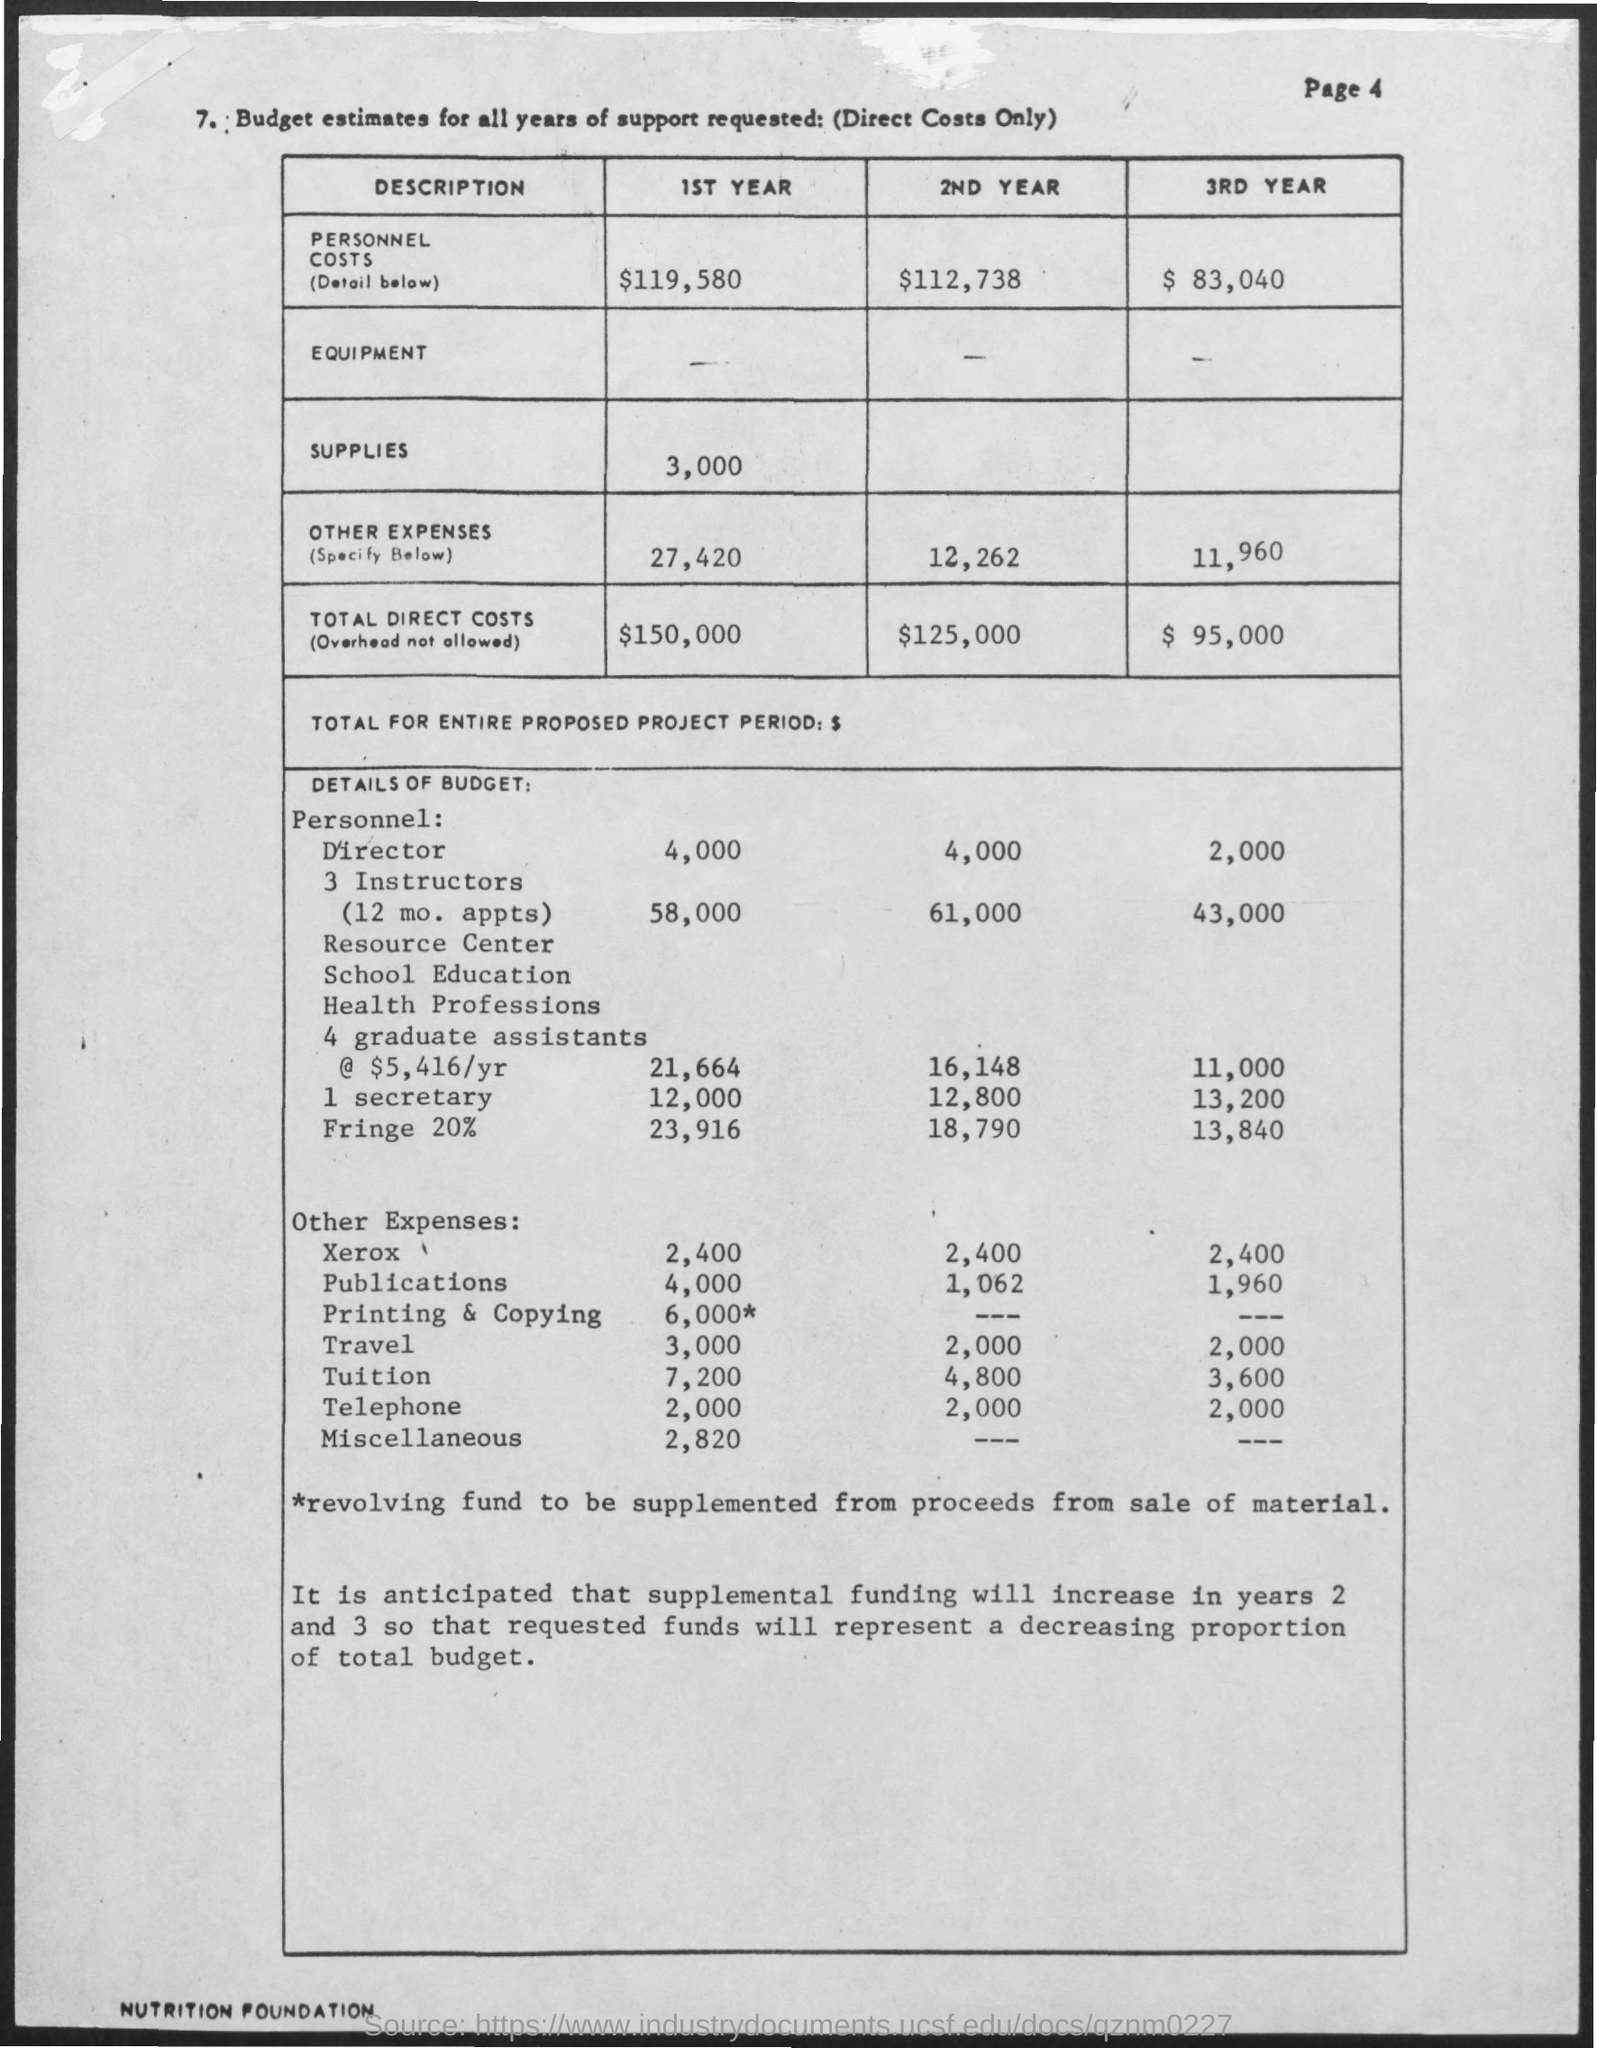What is the amount of total direct costs mentioned in the 1st year ?
Ensure brevity in your answer.  $ 150,000. What is the amount of total direct costs mentioned in the 2nd year ?
Keep it short and to the point. $ 125,000. What is the amount of total direct costs mentioned in the 3rd year ?
Ensure brevity in your answer.  $ 95,000. What  is the amount for supplies mentioned in the 1st year ?
Ensure brevity in your answer.  3,000. What is the amount for personnel costs mentioned in the 1st year ?
Give a very brief answer. $119,580. What is the amount for personnel costs mentioned in the 2nd year ?
Keep it short and to the point. $ 112,738. What is the amount for personnel costs mentioned in the 3rd year ?
Your answer should be compact. $ 83,040. 